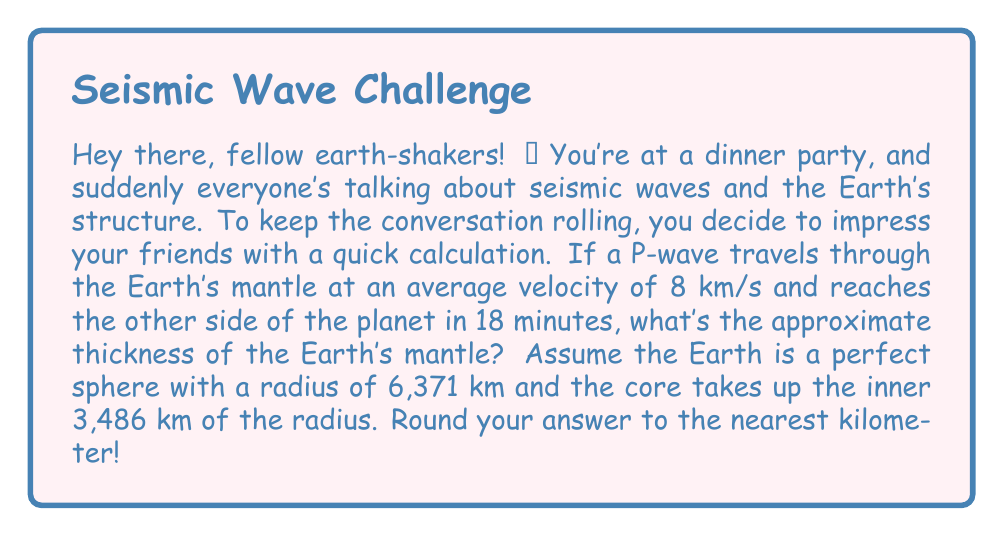Could you help me with this problem? Alright, let's break this down step-by-step:

1) First, we need to find the distance the P-wave travels through the mantle:
   - Time taken = 18 minutes = 1080 seconds
   - Velocity = 8 km/s
   - Distance = Velocity × Time
   $$ \text{Distance} = 8 \text{ km/s} \times 1080 \text{ s} = 8640 \text{ km} $$

2) Now, this distance is actually twice the thickness of the mantle (as the wave goes from one side to the other). So, let's halve it:
   $$ \text{Single mantle thickness} = 8640 \text{ km} \div 2 = 4320 \text{ km} $$

3) But wait! The wave doesn't travel straight through the center. It curves around the core. We need to account for this.

4) The radius of the Earth is 6,371 km, and the core takes up 3,486 km of this. So the mantle should be:
   $$ \text{Expected mantle thickness} = 6371 \text{ km} - 3486 \text{ km} = 2885 \text{ km} $$

5) Our calculated value (4320 km) is larger because of the curvature. To correct for this, we can use the ratio of the arc length to the straight-line distance:
   $$ \text{Correction factor} = \frac{\pi}{2} \approx 1.57 $$

6) Applying this correction:
   $$ \text{Corrected mantle thickness} = \frac{4320 \text{ km}}{1.57} \approx 2752 \text{ km} $$

7) Rounding to the nearest kilometer:
   $$ \text{Final answer} = 2752 \text{ km} $$

This is quite close to the expected 2885 km, considering our simplified model!
Answer: 2752 km 